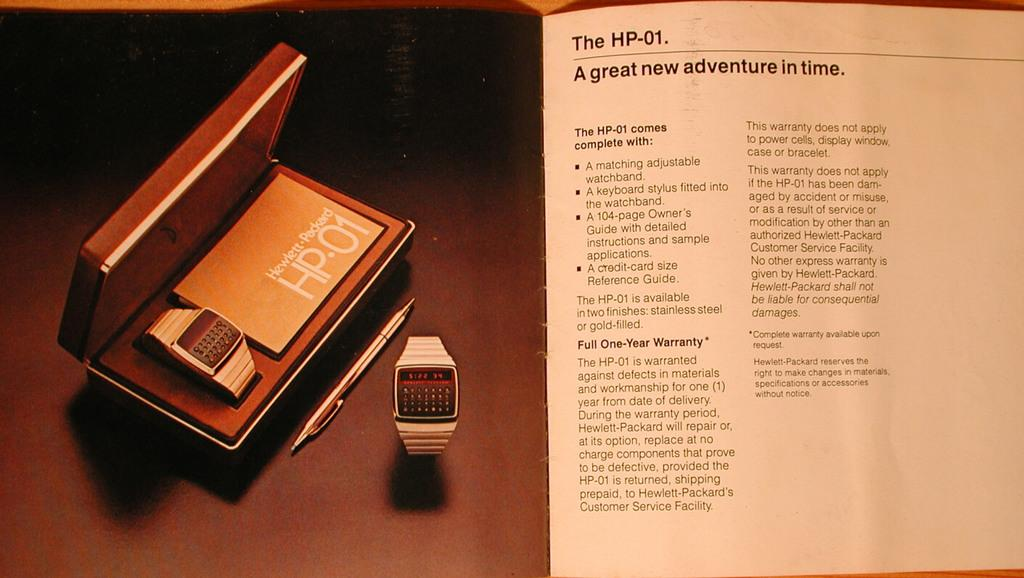Provide a one-sentence caption for the provided image. A brochure for the HP-01 watch is titled "A great new adventure in time". 